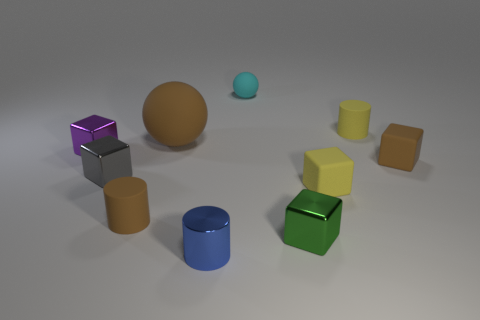Do the gray metallic cube and the yellow cylinder have the same size?
Give a very brief answer. Yes. There is another object that is the same shape as the large object; what color is it?
Give a very brief answer. Cyan. There is a cylinder that is both in front of the brown matte ball and behind the tiny metallic cylinder; what size is it?
Provide a succinct answer. Small. How many objects are either large yellow matte cylinders or tiny rubber cylinders that are on the left side of the tiny cyan thing?
Offer a very short reply. 1. What is the color of the small cylinder on the right side of the tiny yellow matte cube?
Give a very brief answer. Yellow. What is the shape of the tiny green thing?
Ensure brevity in your answer.  Cube. The small cylinder that is to the right of the small cylinder that is in front of the tiny green cube is made of what material?
Keep it short and to the point. Rubber. What number of other objects are the same material as the small yellow block?
Offer a very short reply. 5. There is a blue cylinder that is the same size as the purple metal block; what is it made of?
Your answer should be compact. Metal. Is the number of yellow matte objects to the left of the big brown ball greater than the number of tiny metal blocks behind the cyan matte ball?
Your answer should be very brief. No. 